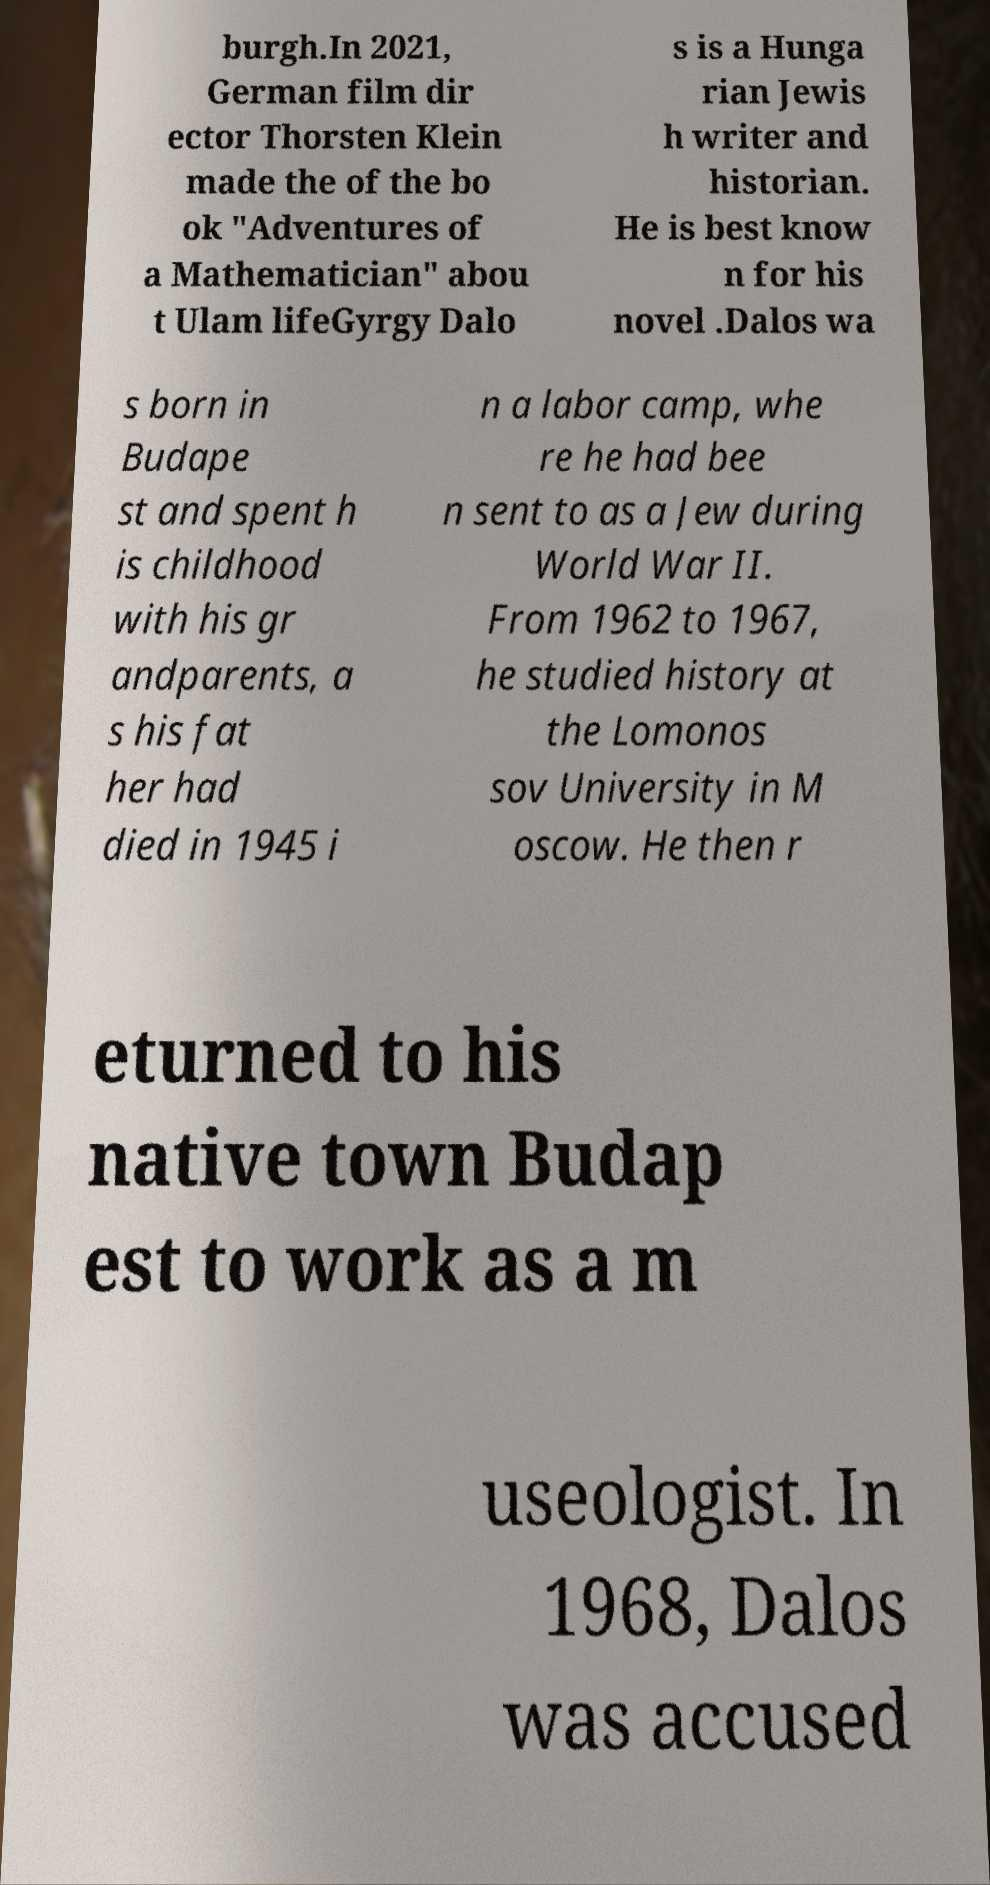What messages or text are displayed in this image? I need them in a readable, typed format. burgh.In 2021, German film dir ector Thorsten Klein made the of the bo ok "Adventures of a Mathematician" abou t Ulam lifeGyrgy Dalo s is a Hunga rian Jewis h writer and historian. He is best know n for his novel .Dalos wa s born in Budape st and spent h is childhood with his gr andparents, a s his fat her had died in 1945 i n a labor camp, whe re he had bee n sent to as a Jew during World War II. From 1962 to 1967, he studied history at the Lomonos sov University in M oscow. He then r eturned to his native town Budap est to work as a m useologist. In 1968, Dalos was accused 